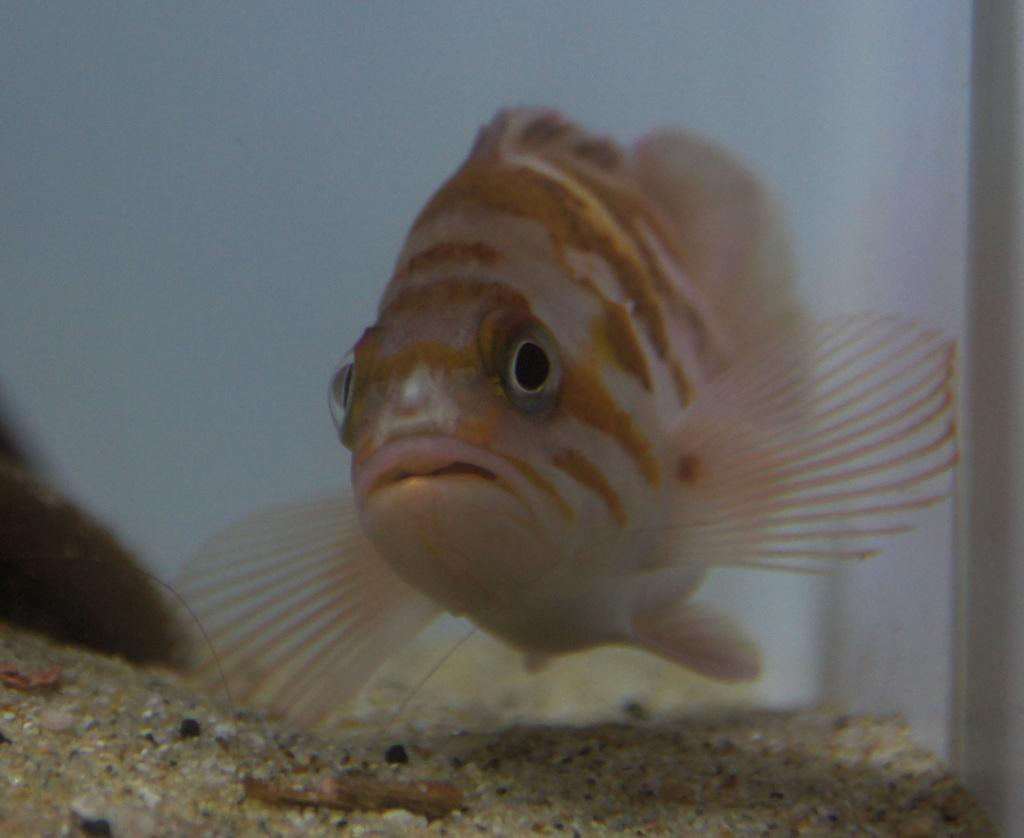What type of animal is in the image? There is a fish in the image. What is the environment in which the fish is located? The fish is in water. What type of surface is visible in the image? There is sand in the image. Where might the image have been taken? The image appears to be taken in an aquarium, which is likely located in a house. What type of veil is draped over the fish in the image? There is no veil present in the image; the fish is in water and surrounded by sand. 